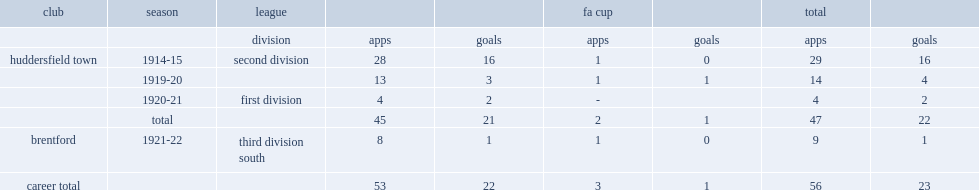How many league goals did ralph shields play for huddersfield town in 1919-20? 3.0. 